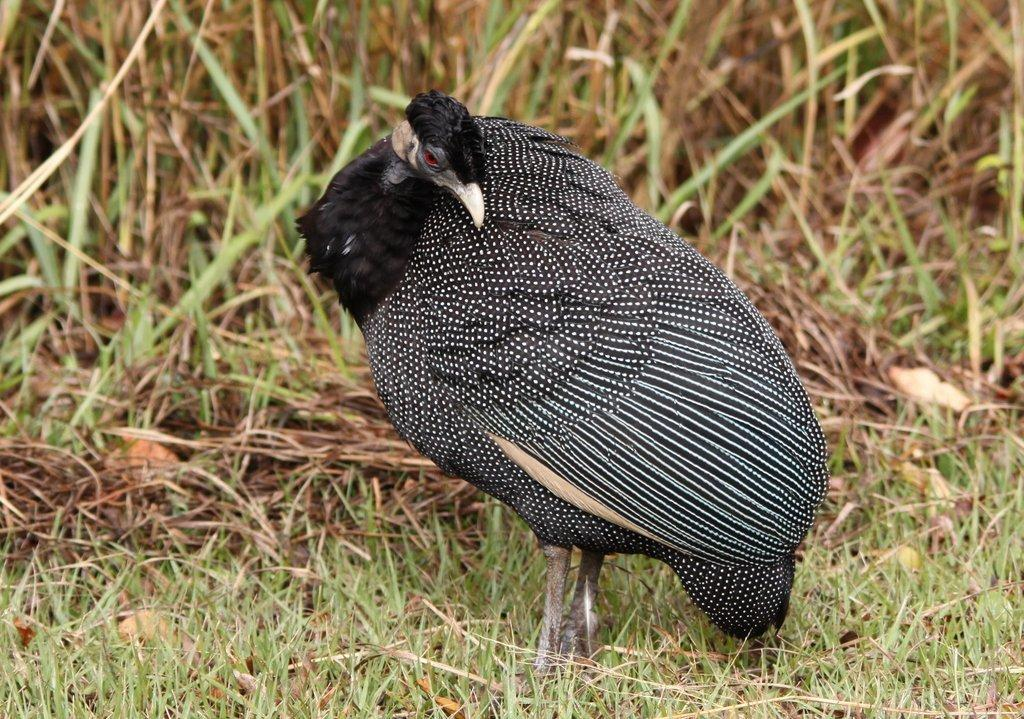What type of animal can be seen in the image? There is a bird in the image. What is the bird's position in the image? The bird is standing on the ground. What type of vegetation is visible in the background of the image? There is grass visible in the background of the image. What type of quarter can be seen in the image? There is no quarter present in the image. Can you hear any thunder in the image? The image is silent, and there is no indication of thunder. 